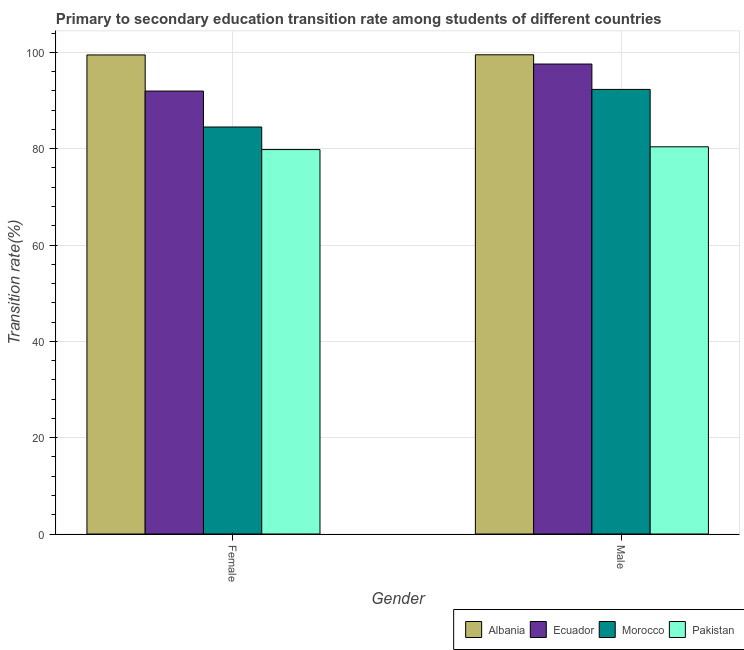How many different coloured bars are there?
Keep it short and to the point. 4. Are the number of bars per tick equal to the number of legend labels?
Your response must be concise. Yes. What is the transition rate among female students in Albania?
Offer a terse response. 99.47. Across all countries, what is the maximum transition rate among male students?
Your response must be concise. 99.5. Across all countries, what is the minimum transition rate among male students?
Keep it short and to the point. 80.4. In which country was the transition rate among female students maximum?
Make the answer very short. Albania. What is the total transition rate among female students in the graph?
Ensure brevity in your answer.  355.78. What is the difference between the transition rate among male students in Pakistan and that in Albania?
Keep it short and to the point. -19.11. What is the difference between the transition rate among female students in Ecuador and the transition rate among male students in Albania?
Ensure brevity in your answer.  -7.53. What is the average transition rate among male students per country?
Keep it short and to the point. 92.45. What is the difference between the transition rate among male students and transition rate among female students in Pakistan?
Give a very brief answer. 0.57. What is the ratio of the transition rate among male students in Albania to that in Morocco?
Make the answer very short. 1.08. Is the transition rate among male students in Ecuador less than that in Pakistan?
Provide a succinct answer. No. What does the 3rd bar from the left in Female represents?
Offer a terse response. Morocco. What does the 4th bar from the right in Male represents?
Offer a very short reply. Albania. Are all the bars in the graph horizontal?
Keep it short and to the point. No. How many countries are there in the graph?
Make the answer very short. 4. Does the graph contain any zero values?
Make the answer very short. No. Where does the legend appear in the graph?
Offer a very short reply. Bottom right. How are the legend labels stacked?
Your answer should be very brief. Horizontal. What is the title of the graph?
Keep it short and to the point. Primary to secondary education transition rate among students of different countries. What is the label or title of the X-axis?
Give a very brief answer. Gender. What is the label or title of the Y-axis?
Your response must be concise. Transition rate(%). What is the Transition rate(%) of Albania in Female?
Ensure brevity in your answer.  99.47. What is the Transition rate(%) in Ecuador in Female?
Provide a short and direct response. 91.97. What is the Transition rate(%) in Morocco in Female?
Provide a short and direct response. 84.51. What is the Transition rate(%) of Pakistan in Female?
Provide a succinct answer. 79.82. What is the Transition rate(%) of Albania in Male?
Provide a succinct answer. 99.5. What is the Transition rate(%) in Ecuador in Male?
Your response must be concise. 97.58. What is the Transition rate(%) in Morocco in Male?
Keep it short and to the point. 92.31. What is the Transition rate(%) in Pakistan in Male?
Offer a terse response. 80.4. Across all Gender, what is the maximum Transition rate(%) of Albania?
Your answer should be compact. 99.5. Across all Gender, what is the maximum Transition rate(%) in Ecuador?
Your answer should be very brief. 97.58. Across all Gender, what is the maximum Transition rate(%) of Morocco?
Offer a terse response. 92.31. Across all Gender, what is the maximum Transition rate(%) in Pakistan?
Your answer should be compact. 80.4. Across all Gender, what is the minimum Transition rate(%) of Albania?
Offer a terse response. 99.47. Across all Gender, what is the minimum Transition rate(%) in Ecuador?
Offer a very short reply. 91.97. Across all Gender, what is the minimum Transition rate(%) in Morocco?
Your answer should be compact. 84.51. Across all Gender, what is the minimum Transition rate(%) in Pakistan?
Provide a short and direct response. 79.82. What is the total Transition rate(%) of Albania in the graph?
Provide a succinct answer. 198.98. What is the total Transition rate(%) of Ecuador in the graph?
Ensure brevity in your answer.  189.56. What is the total Transition rate(%) of Morocco in the graph?
Ensure brevity in your answer.  176.82. What is the total Transition rate(%) in Pakistan in the graph?
Provide a short and direct response. 160.22. What is the difference between the Transition rate(%) of Albania in Female and that in Male?
Ensure brevity in your answer.  -0.03. What is the difference between the Transition rate(%) in Ecuador in Female and that in Male?
Give a very brief answer. -5.61. What is the difference between the Transition rate(%) of Morocco in Female and that in Male?
Give a very brief answer. -7.8. What is the difference between the Transition rate(%) in Pakistan in Female and that in Male?
Offer a very short reply. -0.57. What is the difference between the Transition rate(%) in Albania in Female and the Transition rate(%) in Ecuador in Male?
Provide a succinct answer. 1.89. What is the difference between the Transition rate(%) in Albania in Female and the Transition rate(%) in Morocco in Male?
Offer a terse response. 7.16. What is the difference between the Transition rate(%) of Albania in Female and the Transition rate(%) of Pakistan in Male?
Provide a succinct answer. 19.08. What is the difference between the Transition rate(%) of Ecuador in Female and the Transition rate(%) of Morocco in Male?
Your answer should be very brief. -0.34. What is the difference between the Transition rate(%) of Ecuador in Female and the Transition rate(%) of Pakistan in Male?
Provide a succinct answer. 11.57. What is the difference between the Transition rate(%) in Morocco in Female and the Transition rate(%) in Pakistan in Male?
Your answer should be very brief. 4.11. What is the average Transition rate(%) of Albania per Gender?
Give a very brief answer. 99.49. What is the average Transition rate(%) in Ecuador per Gender?
Your answer should be very brief. 94.78. What is the average Transition rate(%) of Morocco per Gender?
Provide a succinct answer. 88.41. What is the average Transition rate(%) in Pakistan per Gender?
Offer a very short reply. 80.11. What is the difference between the Transition rate(%) in Albania and Transition rate(%) in Ecuador in Female?
Provide a succinct answer. 7.5. What is the difference between the Transition rate(%) of Albania and Transition rate(%) of Morocco in Female?
Your response must be concise. 14.96. What is the difference between the Transition rate(%) of Albania and Transition rate(%) of Pakistan in Female?
Provide a succinct answer. 19.65. What is the difference between the Transition rate(%) of Ecuador and Transition rate(%) of Morocco in Female?
Offer a terse response. 7.46. What is the difference between the Transition rate(%) of Ecuador and Transition rate(%) of Pakistan in Female?
Your response must be concise. 12.15. What is the difference between the Transition rate(%) of Morocco and Transition rate(%) of Pakistan in Female?
Ensure brevity in your answer.  4.69. What is the difference between the Transition rate(%) in Albania and Transition rate(%) in Ecuador in Male?
Your response must be concise. 1.92. What is the difference between the Transition rate(%) in Albania and Transition rate(%) in Morocco in Male?
Keep it short and to the point. 7.19. What is the difference between the Transition rate(%) in Albania and Transition rate(%) in Pakistan in Male?
Make the answer very short. 19.11. What is the difference between the Transition rate(%) of Ecuador and Transition rate(%) of Morocco in Male?
Make the answer very short. 5.27. What is the difference between the Transition rate(%) of Ecuador and Transition rate(%) of Pakistan in Male?
Provide a short and direct response. 17.19. What is the difference between the Transition rate(%) in Morocco and Transition rate(%) in Pakistan in Male?
Keep it short and to the point. 11.92. What is the ratio of the Transition rate(%) in Ecuador in Female to that in Male?
Your answer should be very brief. 0.94. What is the ratio of the Transition rate(%) in Morocco in Female to that in Male?
Offer a very short reply. 0.92. What is the ratio of the Transition rate(%) of Pakistan in Female to that in Male?
Provide a short and direct response. 0.99. What is the difference between the highest and the second highest Transition rate(%) in Albania?
Make the answer very short. 0.03. What is the difference between the highest and the second highest Transition rate(%) of Ecuador?
Make the answer very short. 5.61. What is the difference between the highest and the second highest Transition rate(%) of Morocco?
Provide a succinct answer. 7.8. What is the difference between the highest and the second highest Transition rate(%) in Pakistan?
Provide a short and direct response. 0.57. What is the difference between the highest and the lowest Transition rate(%) in Albania?
Your answer should be compact. 0.03. What is the difference between the highest and the lowest Transition rate(%) in Ecuador?
Provide a succinct answer. 5.61. What is the difference between the highest and the lowest Transition rate(%) of Morocco?
Keep it short and to the point. 7.8. What is the difference between the highest and the lowest Transition rate(%) of Pakistan?
Keep it short and to the point. 0.57. 